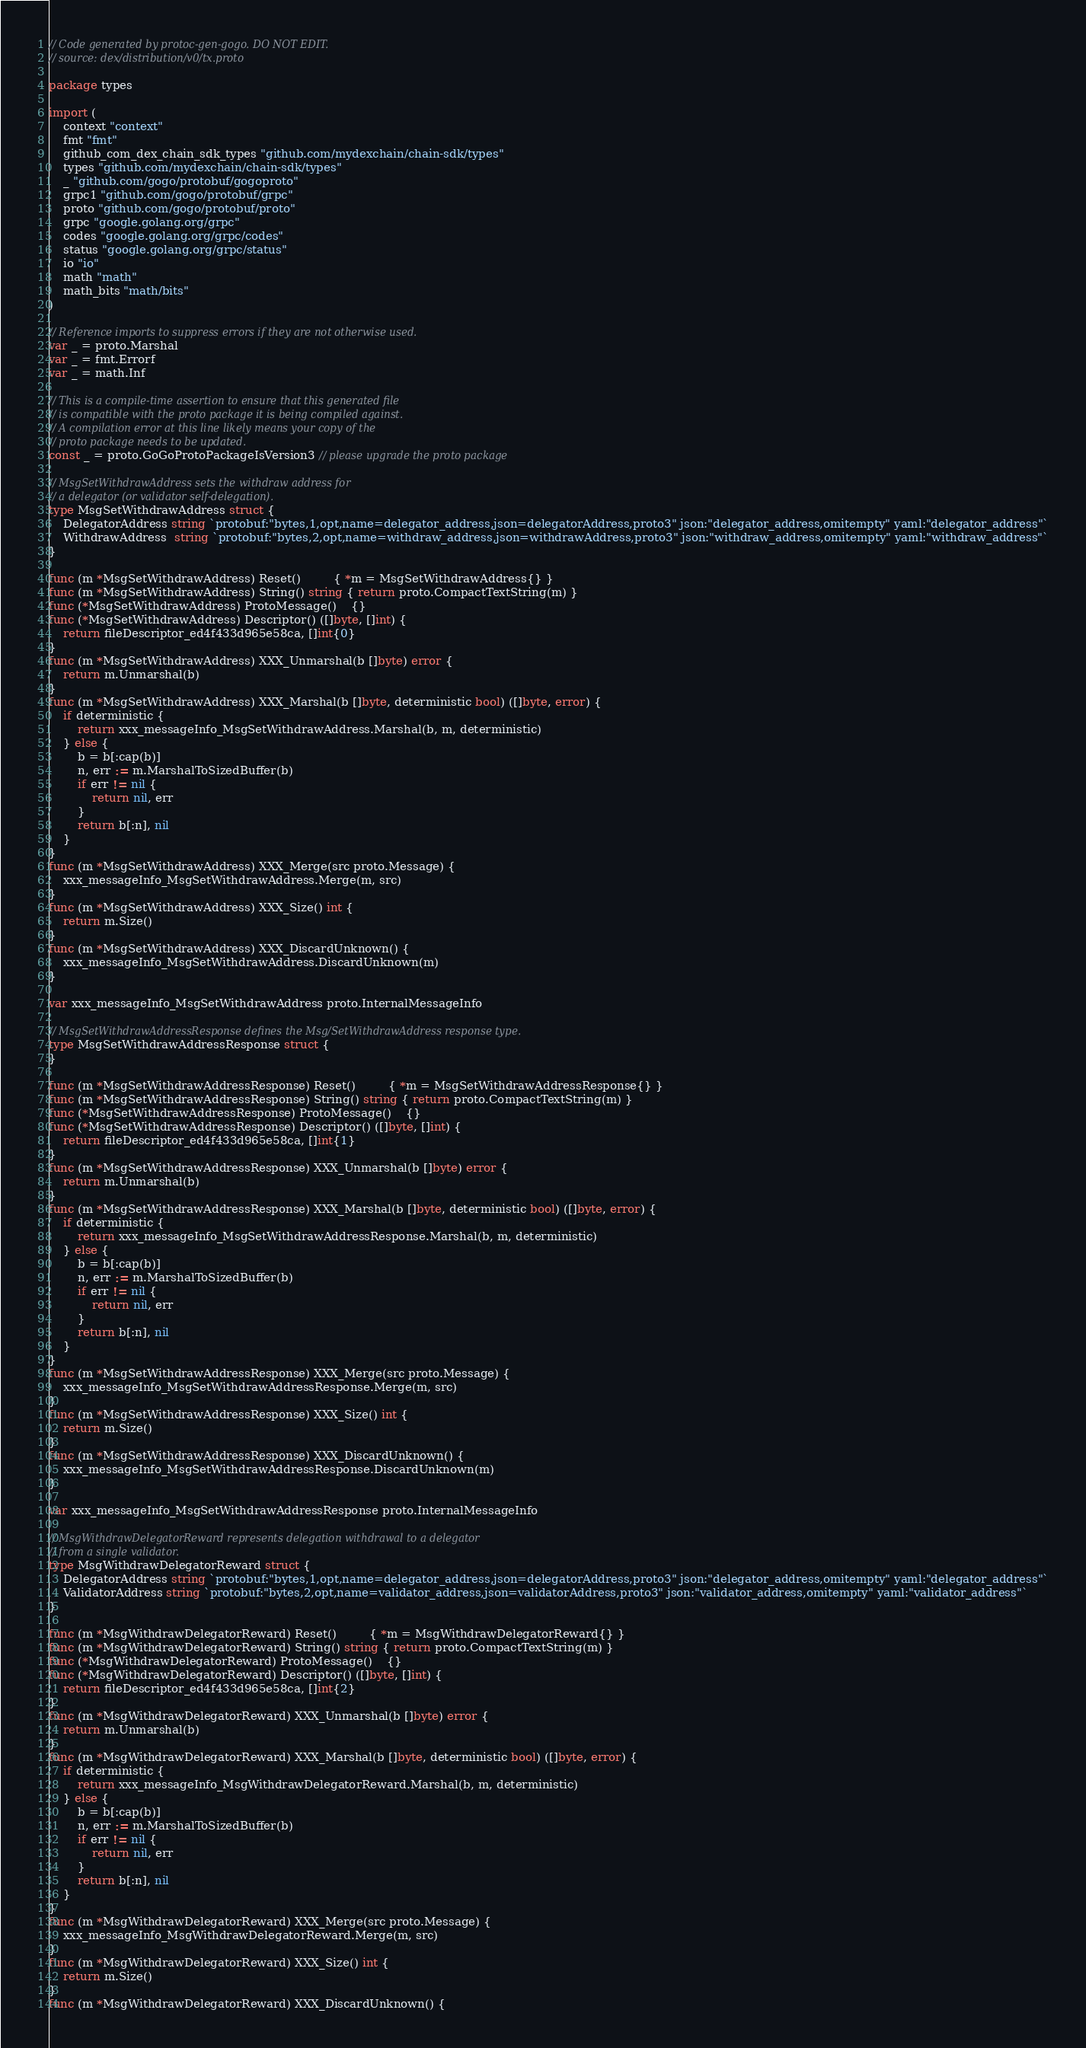Convert code to text. <code><loc_0><loc_0><loc_500><loc_500><_Go_>// Code generated by protoc-gen-gogo. DO NOT EDIT.
// source: dex/distribution/v0/tx.proto

package types

import (
	context "context"
	fmt "fmt"
	github_com_dex_chain_sdk_types "github.com/mydexchain/chain-sdk/types"
	types "github.com/mydexchain/chain-sdk/types"
	_ "github.com/gogo/protobuf/gogoproto"
	grpc1 "github.com/gogo/protobuf/grpc"
	proto "github.com/gogo/protobuf/proto"
	grpc "google.golang.org/grpc"
	codes "google.golang.org/grpc/codes"
	status "google.golang.org/grpc/status"
	io "io"
	math "math"
	math_bits "math/bits"
)

// Reference imports to suppress errors if they are not otherwise used.
var _ = proto.Marshal
var _ = fmt.Errorf
var _ = math.Inf

// This is a compile-time assertion to ensure that this generated file
// is compatible with the proto package it is being compiled against.
// A compilation error at this line likely means your copy of the
// proto package needs to be updated.
const _ = proto.GoGoProtoPackageIsVersion3 // please upgrade the proto package

// MsgSetWithdrawAddress sets the withdraw address for
// a delegator (or validator self-delegation).
type MsgSetWithdrawAddress struct {
	DelegatorAddress string `protobuf:"bytes,1,opt,name=delegator_address,json=delegatorAddress,proto3" json:"delegator_address,omitempty" yaml:"delegator_address"`
	WithdrawAddress  string `protobuf:"bytes,2,opt,name=withdraw_address,json=withdrawAddress,proto3" json:"withdraw_address,omitempty" yaml:"withdraw_address"`
}

func (m *MsgSetWithdrawAddress) Reset()         { *m = MsgSetWithdrawAddress{} }
func (m *MsgSetWithdrawAddress) String() string { return proto.CompactTextString(m) }
func (*MsgSetWithdrawAddress) ProtoMessage()    {}
func (*MsgSetWithdrawAddress) Descriptor() ([]byte, []int) {
	return fileDescriptor_ed4f433d965e58ca, []int{0}
}
func (m *MsgSetWithdrawAddress) XXX_Unmarshal(b []byte) error {
	return m.Unmarshal(b)
}
func (m *MsgSetWithdrawAddress) XXX_Marshal(b []byte, deterministic bool) ([]byte, error) {
	if deterministic {
		return xxx_messageInfo_MsgSetWithdrawAddress.Marshal(b, m, deterministic)
	} else {
		b = b[:cap(b)]
		n, err := m.MarshalToSizedBuffer(b)
		if err != nil {
			return nil, err
		}
		return b[:n], nil
	}
}
func (m *MsgSetWithdrawAddress) XXX_Merge(src proto.Message) {
	xxx_messageInfo_MsgSetWithdrawAddress.Merge(m, src)
}
func (m *MsgSetWithdrawAddress) XXX_Size() int {
	return m.Size()
}
func (m *MsgSetWithdrawAddress) XXX_DiscardUnknown() {
	xxx_messageInfo_MsgSetWithdrawAddress.DiscardUnknown(m)
}

var xxx_messageInfo_MsgSetWithdrawAddress proto.InternalMessageInfo

// MsgSetWithdrawAddressResponse defines the Msg/SetWithdrawAddress response type.
type MsgSetWithdrawAddressResponse struct {
}

func (m *MsgSetWithdrawAddressResponse) Reset()         { *m = MsgSetWithdrawAddressResponse{} }
func (m *MsgSetWithdrawAddressResponse) String() string { return proto.CompactTextString(m) }
func (*MsgSetWithdrawAddressResponse) ProtoMessage()    {}
func (*MsgSetWithdrawAddressResponse) Descriptor() ([]byte, []int) {
	return fileDescriptor_ed4f433d965e58ca, []int{1}
}
func (m *MsgSetWithdrawAddressResponse) XXX_Unmarshal(b []byte) error {
	return m.Unmarshal(b)
}
func (m *MsgSetWithdrawAddressResponse) XXX_Marshal(b []byte, deterministic bool) ([]byte, error) {
	if deterministic {
		return xxx_messageInfo_MsgSetWithdrawAddressResponse.Marshal(b, m, deterministic)
	} else {
		b = b[:cap(b)]
		n, err := m.MarshalToSizedBuffer(b)
		if err != nil {
			return nil, err
		}
		return b[:n], nil
	}
}
func (m *MsgSetWithdrawAddressResponse) XXX_Merge(src proto.Message) {
	xxx_messageInfo_MsgSetWithdrawAddressResponse.Merge(m, src)
}
func (m *MsgSetWithdrawAddressResponse) XXX_Size() int {
	return m.Size()
}
func (m *MsgSetWithdrawAddressResponse) XXX_DiscardUnknown() {
	xxx_messageInfo_MsgSetWithdrawAddressResponse.DiscardUnknown(m)
}

var xxx_messageInfo_MsgSetWithdrawAddressResponse proto.InternalMessageInfo

// MsgWithdrawDelegatorReward represents delegation withdrawal to a delegator
// from a single validator.
type MsgWithdrawDelegatorReward struct {
	DelegatorAddress string `protobuf:"bytes,1,opt,name=delegator_address,json=delegatorAddress,proto3" json:"delegator_address,omitempty" yaml:"delegator_address"`
	ValidatorAddress string `protobuf:"bytes,2,opt,name=validator_address,json=validatorAddress,proto3" json:"validator_address,omitempty" yaml:"validator_address"`
}

func (m *MsgWithdrawDelegatorReward) Reset()         { *m = MsgWithdrawDelegatorReward{} }
func (m *MsgWithdrawDelegatorReward) String() string { return proto.CompactTextString(m) }
func (*MsgWithdrawDelegatorReward) ProtoMessage()    {}
func (*MsgWithdrawDelegatorReward) Descriptor() ([]byte, []int) {
	return fileDescriptor_ed4f433d965e58ca, []int{2}
}
func (m *MsgWithdrawDelegatorReward) XXX_Unmarshal(b []byte) error {
	return m.Unmarshal(b)
}
func (m *MsgWithdrawDelegatorReward) XXX_Marshal(b []byte, deterministic bool) ([]byte, error) {
	if deterministic {
		return xxx_messageInfo_MsgWithdrawDelegatorReward.Marshal(b, m, deterministic)
	} else {
		b = b[:cap(b)]
		n, err := m.MarshalToSizedBuffer(b)
		if err != nil {
			return nil, err
		}
		return b[:n], nil
	}
}
func (m *MsgWithdrawDelegatorReward) XXX_Merge(src proto.Message) {
	xxx_messageInfo_MsgWithdrawDelegatorReward.Merge(m, src)
}
func (m *MsgWithdrawDelegatorReward) XXX_Size() int {
	return m.Size()
}
func (m *MsgWithdrawDelegatorReward) XXX_DiscardUnknown() {</code> 